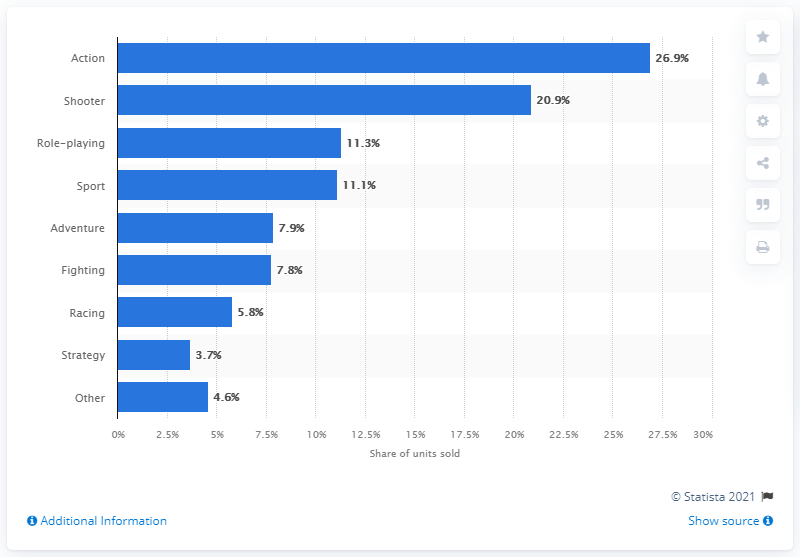Draw attention to some important aspects in this diagram. In 2018, sports games accounted for 11.1% of all video games sold in the United States. 